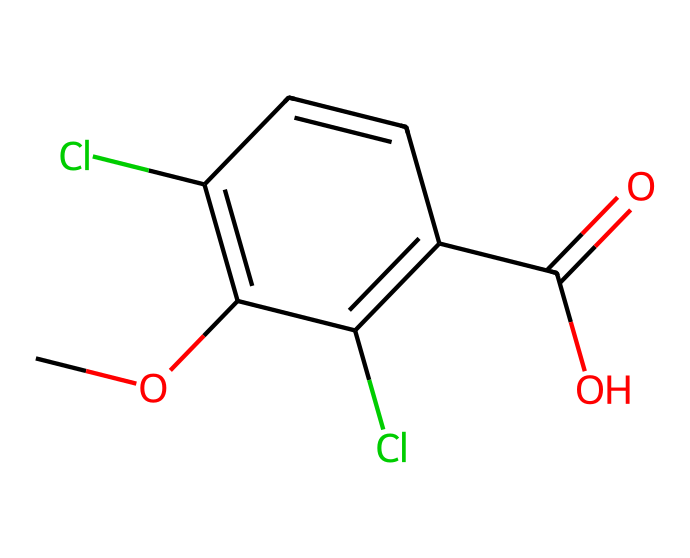What is the molecular formula of dicamba? To determine the molecular formula, count the number of each type of atom in the provided SMILES representation. From the SMILES, we can identify that there are 9 Carbon (C) atoms, 8 Hydrogen (H) atoms, 2 Chlorine (Cl) atoms, and 2 Oxygen (O) atoms. Thus, the molecular formula is C9H8Cl2O2.
Answer: C9H8Cl2O2 How many rings are present in the structure of dicamba? Analyzing the structure related to the provided SMILES, it is evident that there is one aromatic ring indicated by the lower-case 'c' symbols, which represent carbon atoms in a cyclic arrangement. Therefore, there is 1 ring in the structure.
Answer: 1 What functional groups are present in dicamba? To identify the functional groups, look for specific arrangements of atoms that characterize functional groups. In the provided SMILES, we can observe a carboxylic acid group (C(=O)O) as well as ether elements (CO), thus confirming the presence of these functional groups.
Answer: carboxylic acid and ether What type of herbicide is dicamba classified as? Dicamba is classified as a systemic herbicide, which means it is absorbed by the plant and translocated throughout the plant's system to act on unwanted weeds. This classification is inherent in its chemical mechanism of action.
Answer: systemic herbicide How many different types of halogens are present in dicamba? The SMILES notation shows two chlorine atoms (indicated by 'Cl'), and there are no other halogens present in the molecular structure. Hence, we can conclude that there is one type of halogen present.
Answer: 1 What can you infer about the potential for dicamba to drift in the environment? Dicamba's molecular structure, particularly its volatility and systemic nature, suggests a likelihood for drift during application. The presence of aromatic rings might contribute to its stability and allow for movement via air, indicating a greater potential for off-target damage.
Answer: potential for drift 